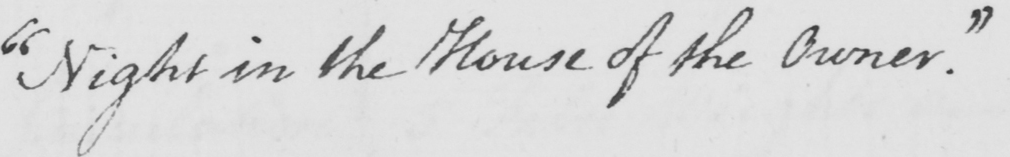Can you read and transcribe this handwriting? " Night in the House of the Owner . " 